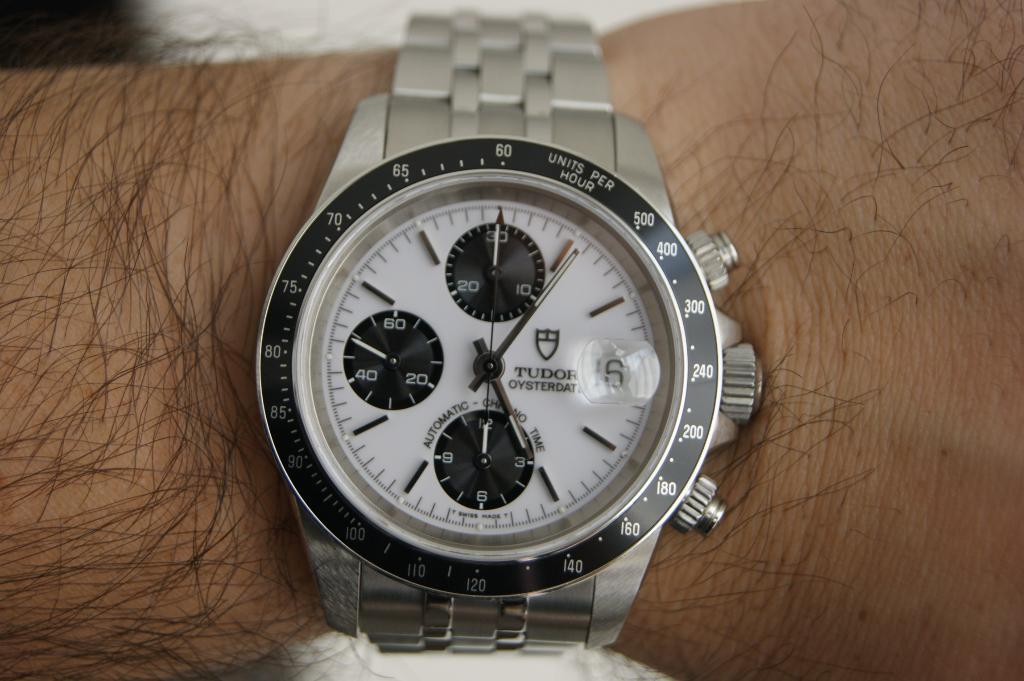<image>
Describe the image concisely. A silver Tudor wrist watch is wrapped around a hairy wrist. 